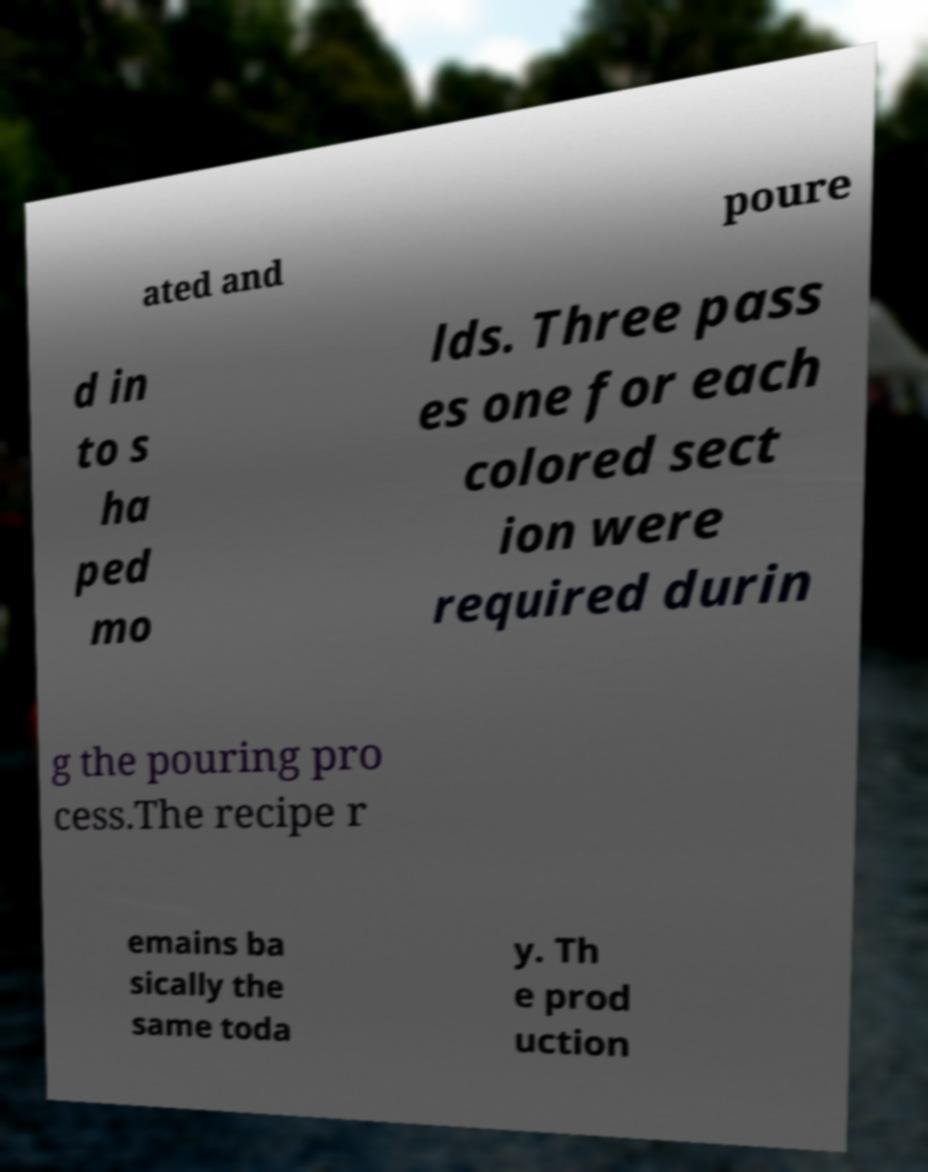Please read and relay the text visible in this image. What does it say? ated and poure d in to s ha ped mo lds. Three pass es one for each colored sect ion were required durin g the pouring pro cess.The recipe r emains ba sically the same toda y. Th e prod uction 